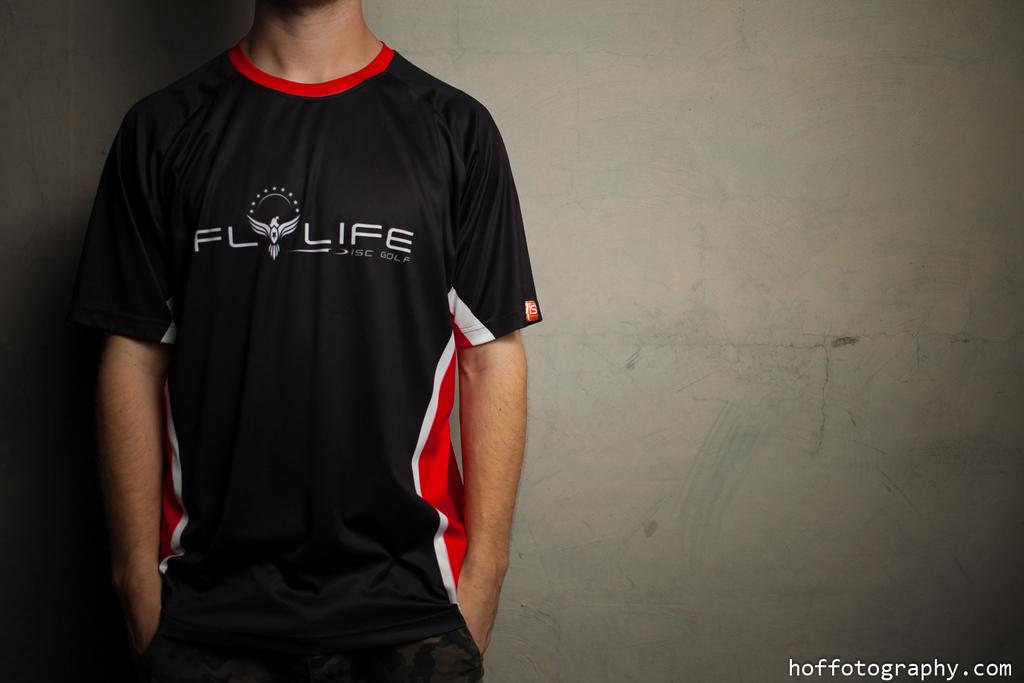What brand is on the shirt?
Give a very brief answer. Flylife. 